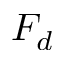<formula> <loc_0><loc_0><loc_500><loc_500>F _ { d }</formula> 